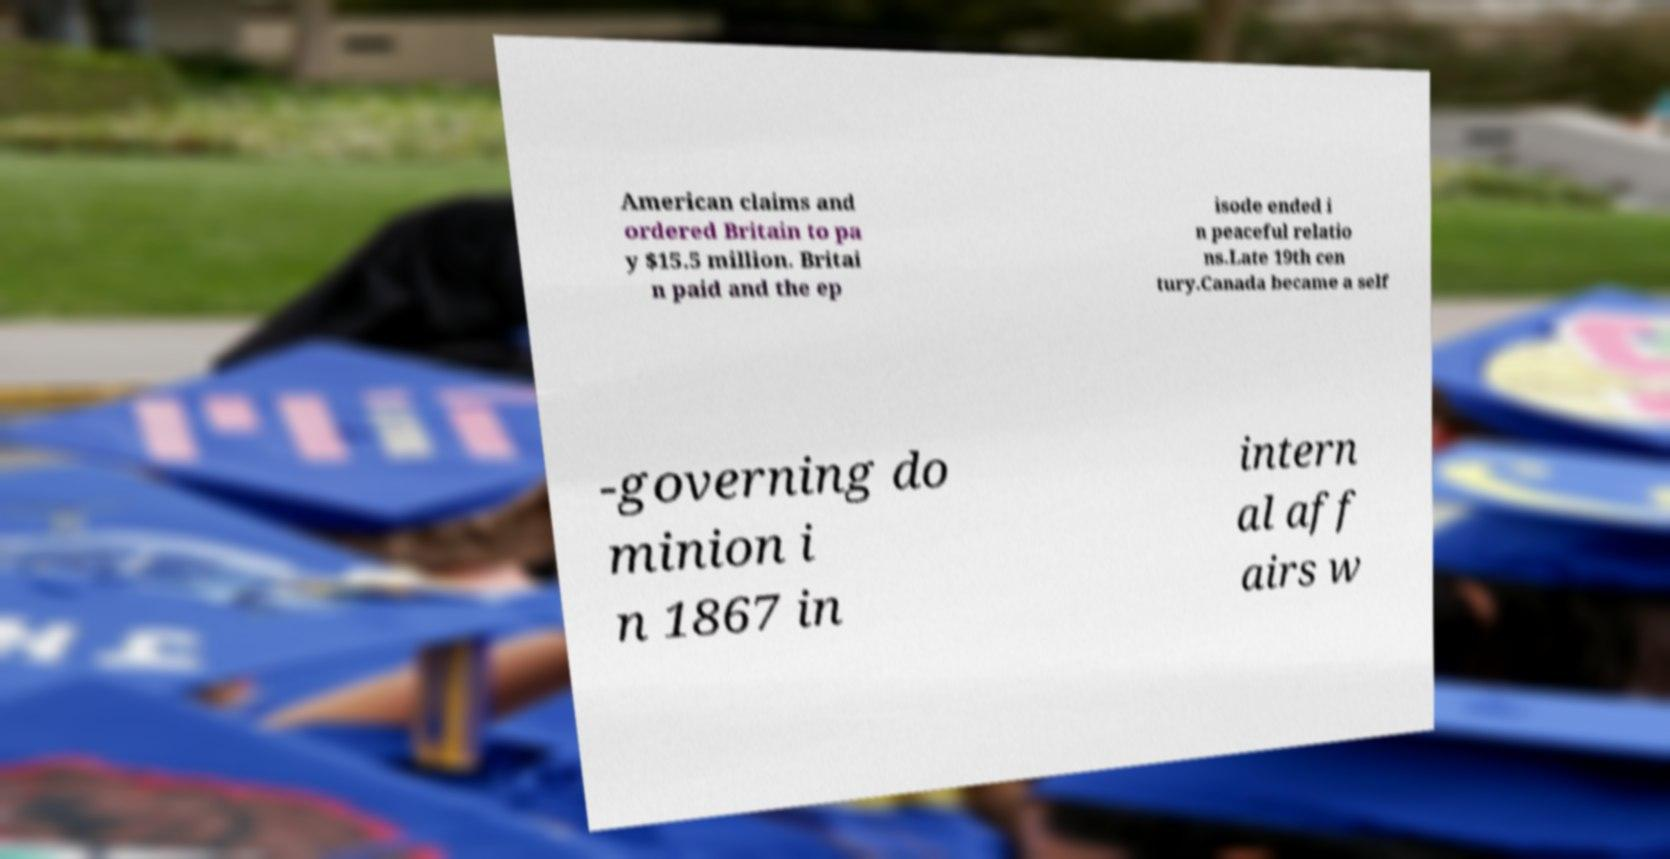There's text embedded in this image that I need extracted. Can you transcribe it verbatim? American claims and ordered Britain to pa y $15.5 million. Britai n paid and the ep isode ended i n peaceful relatio ns.Late 19th cen tury.Canada became a self -governing do minion i n 1867 in intern al aff airs w 